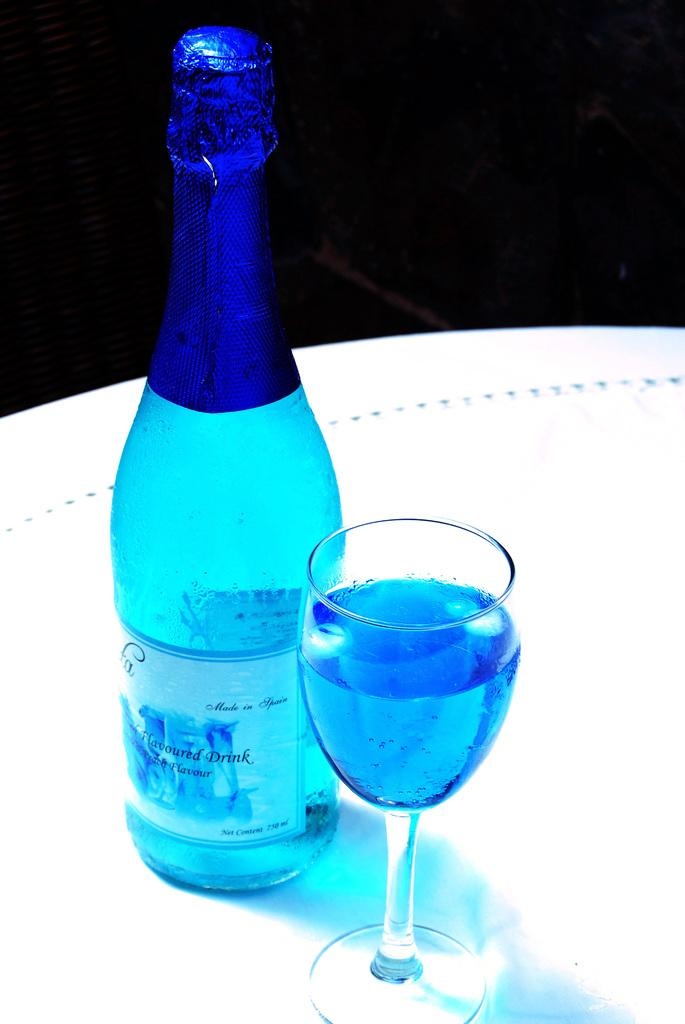What type of beverage is featured in the image? There is a wine bottle and a glass of wine in the image. Where are the wine bottle and the glass of wine located? Both the wine bottle and the glass of wine are on a table. What type of music is being played by the band in the image? There is no band present in the image; it only features a wine bottle and a glass of wine on a table. 